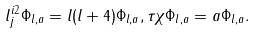Convert formula to latex. <formula><loc_0><loc_0><loc_500><loc_500>l _ { j } ^ { i 2 } \Phi _ { l , a } = l ( l + 4 ) \Phi _ { l , a } , \tau \chi \Phi _ { l , a } = a \Phi _ { l , a } .</formula> 